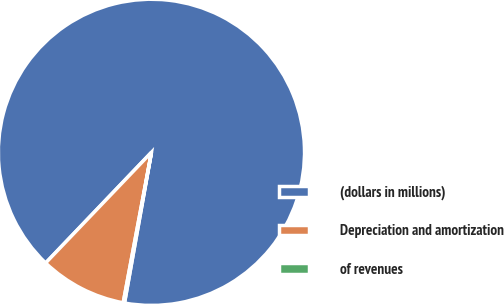Convert chart to OTSL. <chart><loc_0><loc_0><loc_500><loc_500><pie_chart><fcel>(dollars in millions)<fcel>Depreciation and amortization<fcel>of revenues<nl><fcel>90.68%<fcel>9.19%<fcel>0.14%<nl></chart> 